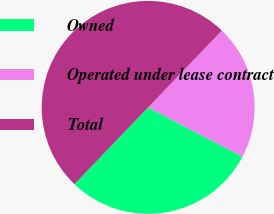Convert chart to OTSL. <chart><loc_0><loc_0><loc_500><loc_500><pie_chart><fcel>Owned<fcel>Operated under lease contract<fcel>Total<nl><fcel>29.49%<fcel>20.51%<fcel>50.0%<nl></chart> 